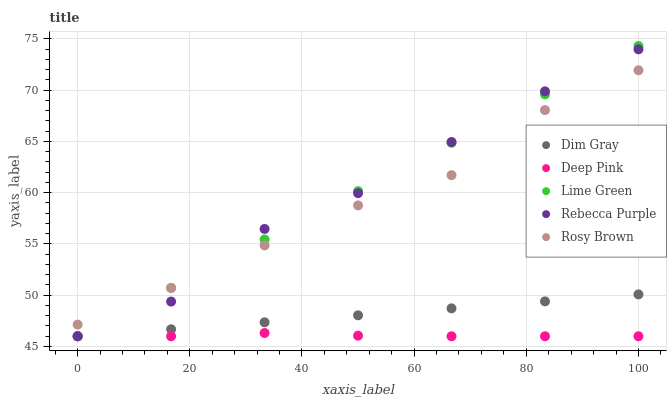Does Deep Pink have the minimum area under the curve?
Answer yes or no. Yes. Does Lime Green have the maximum area under the curve?
Answer yes or no. Yes. Does Dim Gray have the minimum area under the curve?
Answer yes or no. No. Does Dim Gray have the maximum area under the curve?
Answer yes or no. No. Is Lime Green the smoothest?
Answer yes or no. Yes. Is Rebecca Purple the roughest?
Answer yes or no. Yes. Is Dim Gray the smoothest?
Answer yes or no. No. Is Dim Gray the roughest?
Answer yes or no. No. Does Dim Gray have the lowest value?
Answer yes or no. Yes. Does Lime Green have the highest value?
Answer yes or no. Yes. Does Dim Gray have the highest value?
Answer yes or no. No. Is Deep Pink less than Rosy Brown?
Answer yes or no. Yes. Is Rosy Brown greater than Deep Pink?
Answer yes or no. Yes. Does Deep Pink intersect Lime Green?
Answer yes or no. Yes. Is Deep Pink less than Lime Green?
Answer yes or no. No. Is Deep Pink greater than Lime Green?
Answer yes or no. No. Does Deep Pink intersect Rosy Brown?
Answer yes or no. No. 